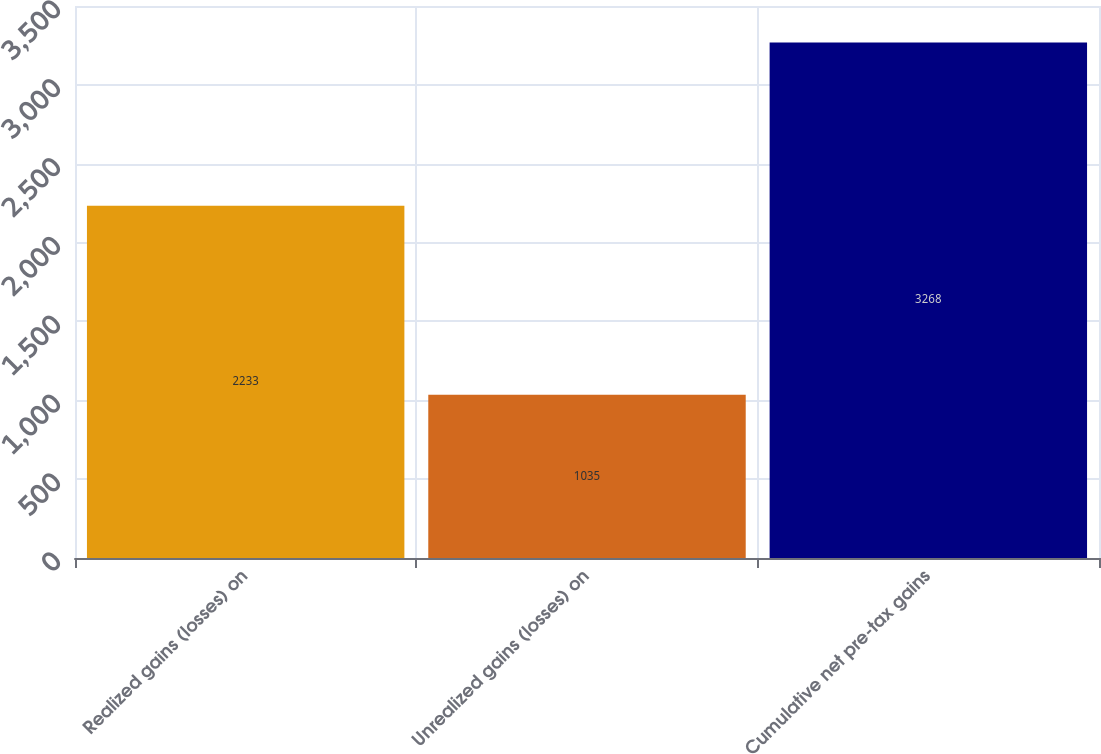Convert chart to OTSL. <chart><loc_0><loc_0><loc_500><loc_500><bar_chart><fcel>Realized gains (losses) on<fcel>Unrealized gains (losses) on<fcel>Cumulative net pre-tax gains<nl><fcel>2233<fcel>1035<fcel>3268<nl></chart> 